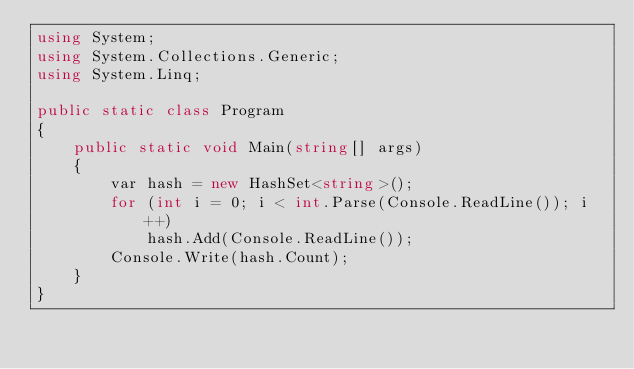<code> <loc_0><loc_0><loc_500><loc_500><_C#_>using System;
using System.Collections.Generic;
using System.Linq;

public static class Program
{
    public static void Main(string[] args)
    {
        var hash = new HashSet<string>();
        for (int i = 0; i < int.Parse(Console.ReadLine()); i++)
            hash.Add(Console.ReadLine());
        Console.Write(hash.Count);
    }
}</code> 